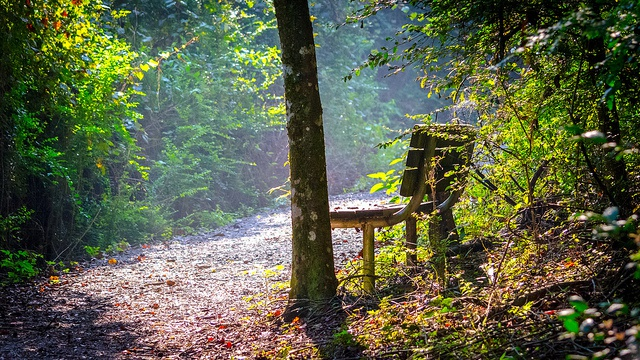Describe the objects in this image and their specific colors. I can see a bench in black and olive tones in this image. 